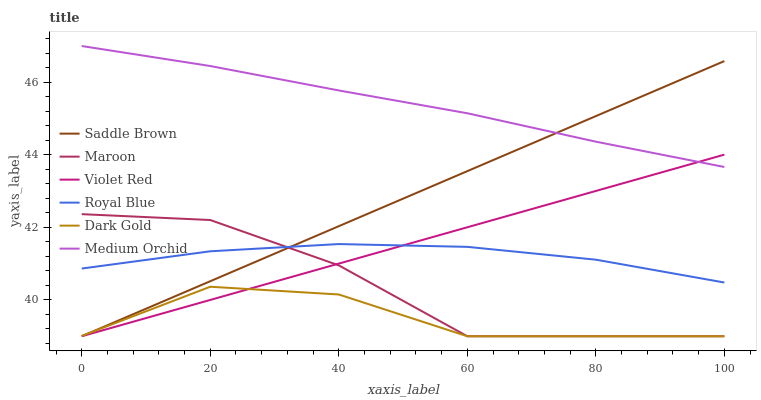Does Dark Gold have the minimum area under the curve?
Answer yes or no. Yes. Does Medium Orchid have the maximum area under the curve?
Answer yes or no. Yes. Does Medium Orchid have the minimum area under the curve?
Answer yes or no. No. Does Dark Gold have the maximum area under the curve?
Answer yes or no. No. Is Violet Red the smoothest?
Answer yes or no. Yes. Is Maroon the roughest?
Answer yes or no. Yes. Is Dark Gold the smoothest?
Answer yes or no. No. Is Dark Gold the roughest?
Answer yes or no. No. Does Violet Red have the lowest value?
Answer yes or no. Yes. Does Medium Orchid have the lowest value?
Answer yes or no. No. Does Medium Orchid have the highest value?
Answer yes or no. Yes. Does Dark Gold have the highest value?
Answer yes or no. No. Is Dark Gold less than Medium Orchid?
Answer yes or no. Yes. Is Medium Orchid greater than Royal Blue?
Answer yes or no. Yes. Does Saddle Brown intersect Violet Red?
Answer yes or no. Yes. Is Saddle Brown less than Violet Red?
Answer yes or no. No. Is Saddle Brown greater than Violet Red?
Answer yes or no. No. Does Dark Gold intersect Medium Orchid?
Answer yes or no. No. 